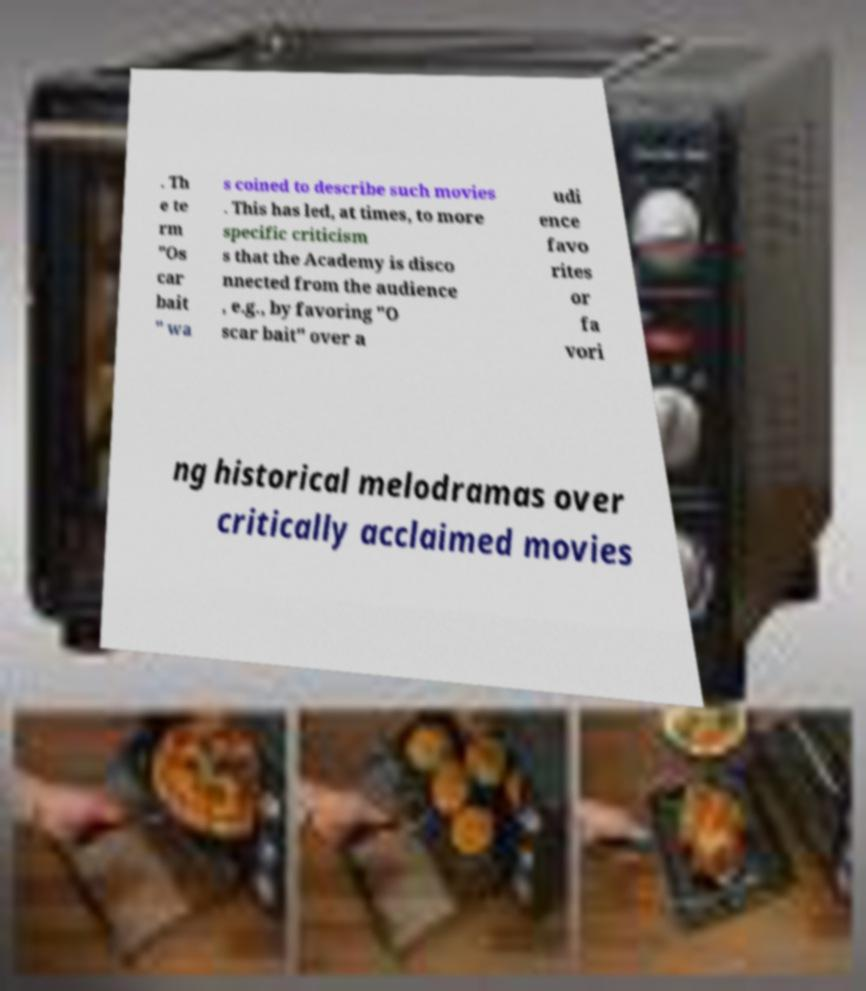I need the written content from this picture converted into text. Can you do that? . Th e te rm "Os car bait " wa s coined to describe such movies . This has led, at times, to more specific criticism s that the Academy is disco nnected from the audience , e.g., by favoring "O scar bait" over a udi ence favo rites or fa vori ng historical melodramas over critically acclaimed movies 